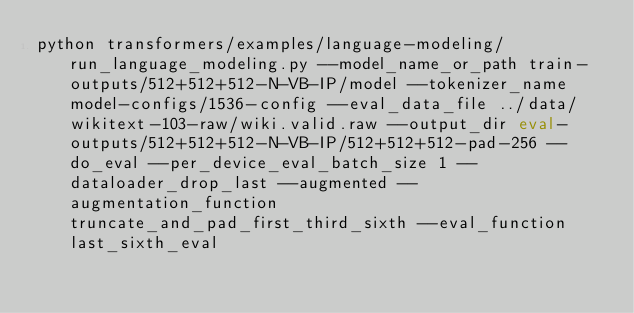Convert code to text. <code><loc_0><loc_0><loc_500><loc_500><_Bash_>python transformers/examples/language-modeling/run_language_modeling.py --model_name_or_path train-outputs/512+512+512-N-VB-IP/model --tokenizer_name model-configs/1536-config --eval_data_file ../data/wikitext-103-raw/wiki.valid.raw --output_dir eval-outputs/512+512+512-N-VB-IP/512+512+512-pad-256 --do_eval --per_device_eval_batch_size 1 --dataloader_drop_last --augmented --augmentation_function truncate_and_pad_first_third_sixth --eval_function last_sixth_eval</code> 